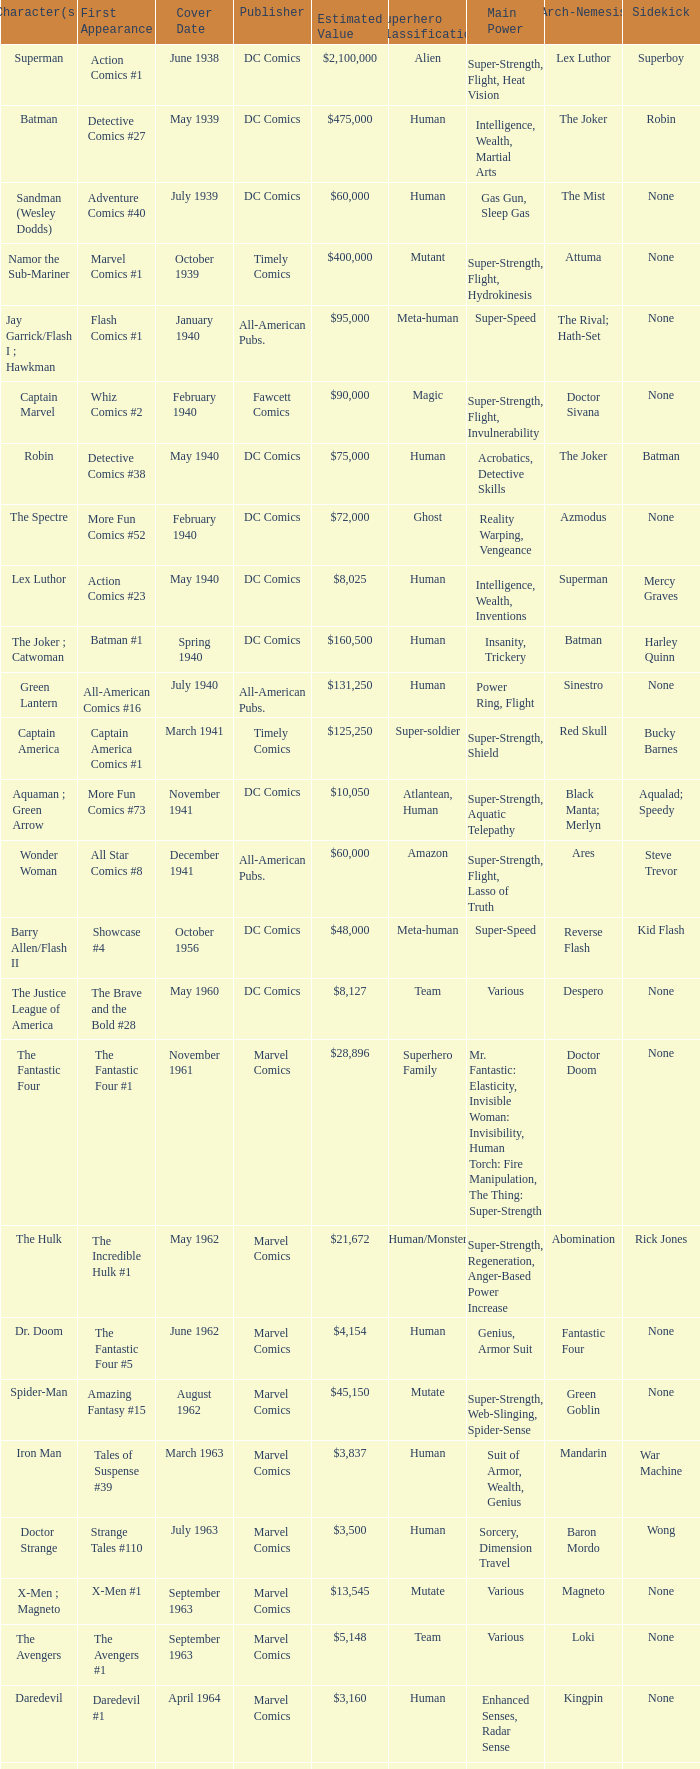Would you mind parsing the complete table? {'header': ['Character(s)', 'First Appearance', 'Cover Date', 'Publisher', 'Estimated Value', 'Superhero Classification', 'Main Power', 'Arch-Nemesis', 'Sidekick'], 'rows': [['Superman', 'Action Comics #1', 'June 1938', 'DC Comics', '$2,100,000', 'Alien', 'Super-Strength, Flight, Heat Vision', 'Lex Luthor', 'Superboy'], ['Batman', 'Detective Comics #27', 'May 1939', 'DC Comics', '$475,000', 'Human', 'Intelligence, Wealth, Martial Arts', 'The Joker', 'Robin'], ['Sandman (Wesley Dodds)', 'Adventure Comics #40', 'July 1939', 'DC Comics', '$60,000', 'Human', 'Gas Gun, Sleep Gas', 'The Mist', 'None'], ['Namor the Sub-Mariner', 'Marvel Comics #1', 'October 1939', 'Timely Comics', '$400,000', 'Mutant', 'Super-Strength, Flight, Hydrokinesis', 'Attuma', 'None'], ['Jay Garrick/Flash I ; Hawkman', 'Flash Comics #1', 'January 1940', 'All-American Pubs.', '$95,000', 'Meta-human', 'Super-Speed', 'The Rival; Hath-Set', 'None'], ['Captain Marvel', 'Whiz Comics #2', 'February 1940', 'Fawcett Comics', '$90,000', 'Magic', 'Super-Strength, Flight, Invulnerability', 'Doctor Sivana', 'None'], ['Robin', 'Detective Comics #38', 'May 1940', 'DC Comics', '$75,000', 'Human', 'Acrobatics, Detective Skills', 'The Joker', 'Batman'], ['The Spectre', 'More Fun Comics #52', 'February 1940', 'DC Comics', '$72,000', 'Ghost', 'Reality Warping, Vengeance', 'Azmodus', 'None'], ['Lex Luthor', 'Action Comics #23', 'May 1940', 'DC Comics', '$8,025', 'Human', 'Intelligence, Wealth, Inventions', 'Superman', 'Mercy Graves'], ['The Joker ; Catwoman', 'Batman #1', 'Spring 1940', 'DC Comics', '$160,500', 'Human', 'Insanity, Trickery', 'Batman', 'Harley Quinn'], ['Green Lantern', 'All-American Comics #16', 'July 1940', 'All-American Pubs.', '$131,250', 'Human', 'Power Ring, Flight', 'Sinestro', 'None'], ['Captain America', 'Captain America Comics #1', 'March 1941', 'Timely Comics', '$125,250', 'Super-soldier', 'Super-Strength, Shield', 'Red Skull', 'Bucky Barnes'], ['Aquaman ; Green Arrow', 'More Fun Comics #73', 'November 1941', 'DC Comics', '$10,050', 'Atlantean, Human', 'Super-Strength, Aquatic Telepathy', 'Black Manta; Merlyn', 'Aqualad; Speedy'], ['Wonder Woman', 'All Star Comics #8', 'December 1941', 'All-American Pubs.', '$60,000', 'Amazon', 'Super-Strength, Flight, Lasso of Truth', 'Ares', 'Steve Trevor'], ['Barry Allen/Flash II', 'Showcase #4', 'October 1956', 'DC Comics', '$48,000', 'Meta-human', 'Super-Speed', 'Reverse Flash', 'Kid Flash'], ['The Justice League of America', 'The Brave and the Bold #28', 'May 1960', 'DC Comics', '$8,127', 'Team', 'Various', 'Despero', 'None'], ['The Fantastic Four', 'The Fantastic Four #1', 'November 1961', 'Marvel Comics', '$28,896', 'Superhero Family', 'Mr. Fantastic: Elasticity, Invisible Woman: Invisibility, Human Torch: Fire Manipulation, The Thing: Super-Strength', 'Doctor Doom', 'None'], ['The Hulk', 'The Incredible Hulk #1', 'May 1962', 'Marvel Comics', '$21,672', 'Human/Monster', 'Super-Strength, Regeneration, Anger-Based Power Increase', 'Abomination', 'Rick Jones'], ['Dr. Doom', 'The Fantastic Four #5', 'June 1962', 'Marvel Comics', '$4,154', 'Human', 'Genius, Armor Suit', 'Fantastic Four', 'None'], ['Spider-Man', 'Amazing Fantasy #15', 'August 1962', 'Marvel Comics', '$45,150', 'Mutate', 'Super-Strength, Web-Slinging, Spider-Sense', 'Green Goblin', 'None'], ['Iron Man', 'Tales of Suspense #39', 'March 1963', 'Marvel Comics', '$3,837', 'Human', 'Suit of Armor, Wealth, Genius', 'Mandarin', 'War Machine'], ['Doctor Strange', 'Strange Tales #110', 'July 1963', 'Marvel Comics', '$3,500', 'Human', 'Sorcery, Dimension Travel', 'Baron Mordo', 'Wong'], ['X-Men ; Magneto', 'X-Men #1', 'September 1963', 'Marvel Comics', '$13,545', 'Mutate', 'Various', 'Magneto', 'None'], ['The Avengers', 'The Avengers #1', 'September 1963', 'Marvel Comics', '$5,148', 'Team', 'Various', 'Loki', 'None'], ['Daredevil', 'Daredevil #1', 'April 1964', 'Marvel Comics', '$3,160', 'Human', 'Enhanced Senses, Radar Sense', 'Kingpin', 'None'], ['Teen Titans', 'The Brave and the Bold #54', 'July 1964', 'DC Comics', '$415', 'Team', 'Various', 'Deathstroke', 'None'], ['The Punisher', 'The Amazing Spider-Man #129', 'February 1974', 'Marvel Comics', '$918', 'Human', 'Military Training, Arsenal of Weapons', 'Jigsaw', 'Microchip'], ['Wolverine', 'The Incredible Hulk #180', 'October 1974', 'Marvel Comics', '$350', 'Mutant', 'Super-Strength, Regeneration, Claws', 'Sabretooth', 'None'], ['Teenage Mutant Ninja Turtles', 'Teenage Mutant Ninja Turtles #1', 'May 1984', 'Mirage Studios', '$2,400', 'Mutate', 'Martial Arts, Weapon Proficiency', 'Shredder', "April O'Neil"]]} Which character first appeared in Amazing Fantasy #15? Spider-Man. 